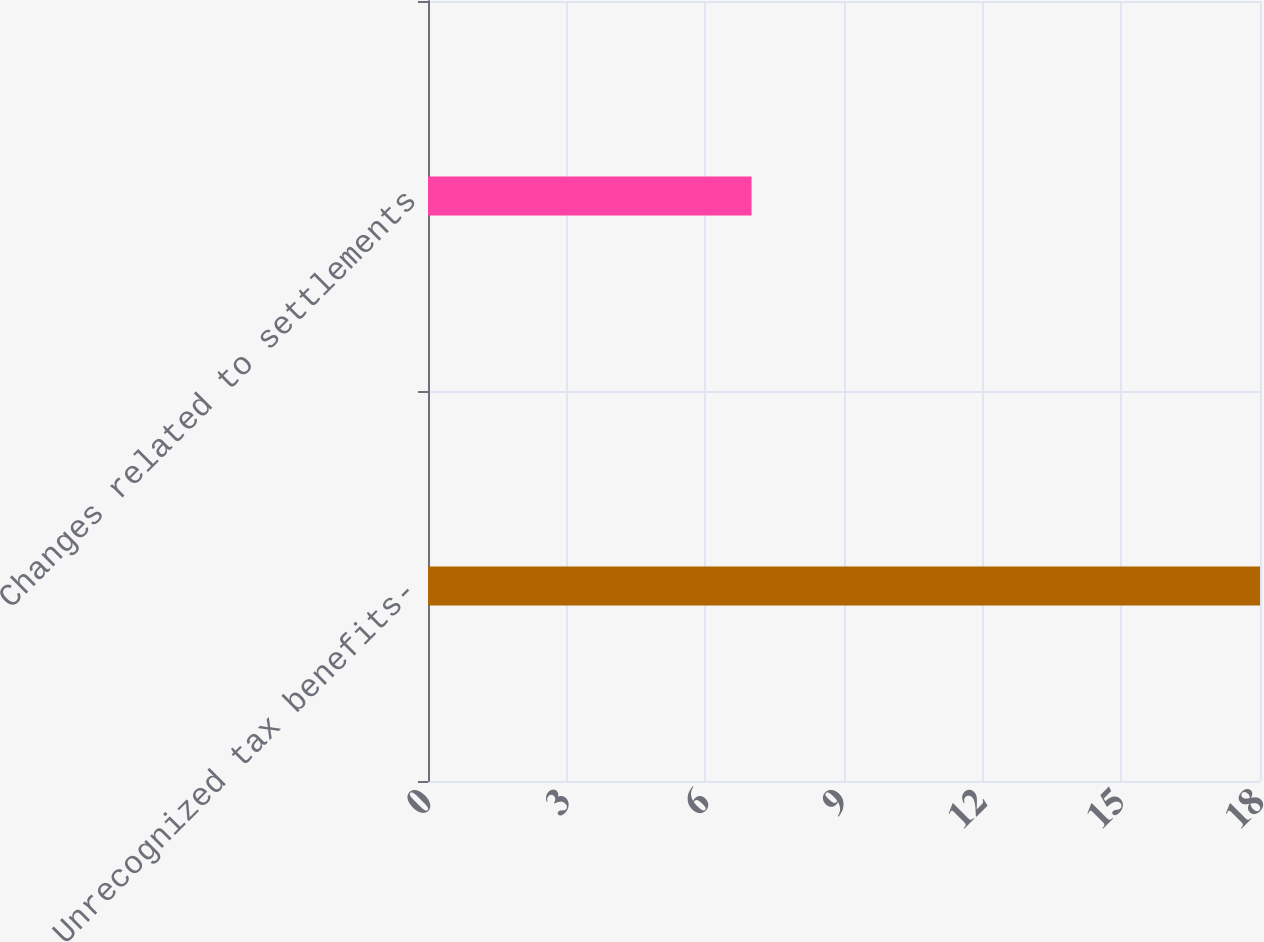Convert chart to OTSL. <chart><loc_0><loc_0><loc_500><loc_500><bar_chart><fcel>Unrecognized tax benefits-<fcel>Changes related to settlements<nl><fcel>18<fcel>7<nl></chart> 